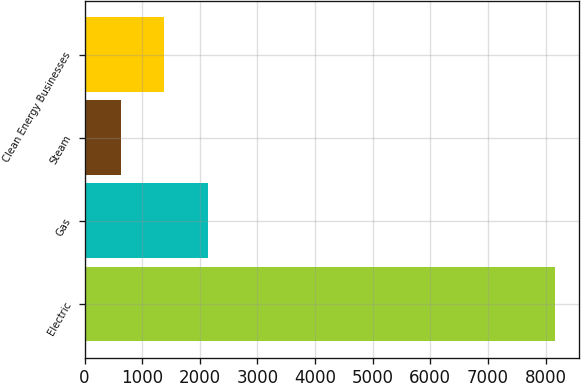Convert chart to OTSL. <chart><loc_0><loc_0><loc_500><loc_500><bar_chart><fcel>Electric<fcel>Gas<fcel>Steam<fcel>Clean Energy Businesses<nl><fcel>8172<fcel>2137.6<fcel>629<fcel>1383.3<nl></chart> 